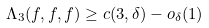Convert formula to latex. <formula><loc_0><loc_0><loc_500><loc_500>\Lambda _ { 3 } ( f , f , f ) \geq c ( 3 , \delta ) - o _ { \delta } ( 1 )</formula> 